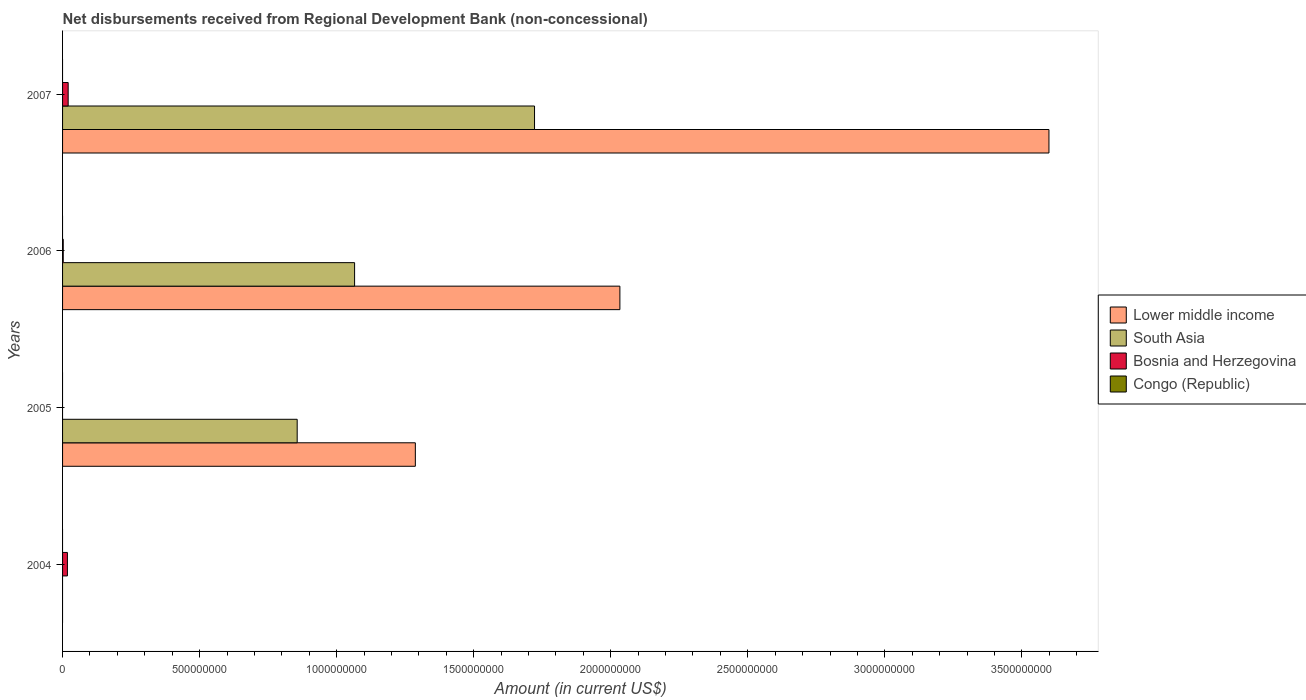Are the number of bars on each tick of the Y-axis equal?
Give a very brief answer. No. How many bars are there on the 2nd tick from the bottom?
Provide a short and direct response. 2. In how many cases, is the number of bars for a given year not equal to the number of legend labels?
Keep it short and to the point. 4. Across all years, what is the maximum amount of disbursements received from Regional Development Bank in Lower middle income?
Your answer should be compact. 3.60e+09. What is the total amount of disbursements received from Regional Development Bank in Congo (Republic) in the graph?
Give a very brief answer. 0. What is the difference between the amount of disbursements received from Regional Development Bank in South Asia in 2005 and that in 2007?
Provide a succinct answer. -8.66e+08. What is the difference between the amount of disbursements received from Regional Development Bank in South Asia in 2004 and the amount of disbursements received from Regional Development Bank in Bosnia and Herzegovina in 2007?
Ensure brevity in your answer.  -2.04e+07. What is the average amount of disbursements received from Regional Development Bank in Congo (Republic) per year?
Ensure brevity in your answer.  0. In the year 2007, what is the difference between the amount of disbursements received from Regional Development Bank in Lower middle income and amount of disbursements received from Regional Development Bank in South Asia?
Give a very brief answer. 1.88e+09. Is the difference between the amount of disbursements received from Regional Development Bank in Lower middle income in 2006 and 2007 greater than the difference between the amount of disbursements received from Regional Development Bank in South Asia in 2006 and 2007?
Give a very brief answer. No. What is the difference between the highest and the second highest amount of disbursements received from Regional Development Bank in South Asia?
Your answer should be very brief. 6.56e+08. What is the difference between the highest and the lowest amount of disbursements received from Regional Development Bank in Lower middle income?
Give a very brief answer. 3.60e+09. Is the sum of the amount of disbursements received from Regional Development Bank in South Asia in 2005 and 2007 greater than the maximum amount of disbursements received from Regional Development Bank in Lower middle income across all years?
Offer a terse response. No. Is it the case that in every year, the sum of the amount of disbursements received from Regional Development Bank in South Asia and amount of disbursements received from Regional Development Bank in Lower middle income is greater than the amount of disbursements received from Regional Development Bank in Congo (Republic)?
Offer a very short reply. No. How many bars are there?
Provide a short and direct response. 9. Are all the bars in the graph horizontal?
Your answer should be very brief. Yes. Does the graph contain grids?
Offer a very short reply. No. Where does the legend appear in the graph?
Keep it short and to the point. Center right. What is the title of the graph?
Make the answer very short. Net disbursements received from Regional Development Bank (non-concessional). What is the label or title of the Y-axis?
Offer a terse response. Years. What is the Amount (in current US$) of Bosnia and Herzegovina in 2004?
Your answer should be very brief. 1.77e+07. What is the Amount (in current US$) of Congo (Republic) in 2004?
Your response must be concise. 0. What is the Amount (in current US$) in Lower middle income in 2005?
Ensure brevity in your answer.  1.29e+09. What is the Amount (in current US$) in South Asia in 2005?
Your answer should be compact. 8.56e+08. What is the Amount (in current US$) in Bosnia and Herzegovina in 2005?
Offer a terse response. 0. What is the Amount (in current US$) in Lower middle income in 2006?
Offer a very short reply. 2.03e+09. What is the Amount (in current US$) of South Asia in 2006?
Keep it short and to the point. 1.07e+09. What is the Amount (in current US$) in Bosnia and Herzegovina in 2006?
Give a very brief answer. 2.46e+06. What is the Amount (in current US$) of Lower middle income in 2007?
Provide a short and direct response. 3.60e+09. What is the Amount (in current US$) in South Asia in 2007?
Your answer should be very brief. 1.72e+09. What is the Amount (in current US$) in Bosnia and Herzegovina in 2007?
Keep it short and to the point. 2.04e+07. Across all years, what is the maximum Amount (in current US$) of Lower middle income?
Your answer should be compact. 3.60e+09. Across all years, what is the maximum Amount (in current US$) in South Asia?
Your response must be concise. 1.72e+09. Across all years, what is the maximum Amount (in current US$) of Bosnia and Herzegovina?
Your answer should be very brief. 2.04e+07. Across all years, what is the minimum Amount (in current US$) of Lower middle income?
Make the answer very short. 0. What is the total Amount (in current US$) of Lower middle income in the graph?
Provide a succinct answer. 6.92e+09. What is the total Amount (in current US$) of South Asia in the graph?
Provide a short and direct response. 3.64e+09. What is the total Amount (in current US$) of Bosnia and Herzegovina in the graph?
Offer a terse response. 4.06e+07. What is the difference between the Amount (in current US$) in Bosnia and Herzegovina in 2004 and that in 2006?
Your response must be concise. 1.53e+07. What is the difference between the Amount (in current US$) in Bosnia and Herzegovina in 2004 and that in 2007?
Make the answer very short. -2.73e+06. What is the difference between the Amount (in current US$) in Lower middle income in 2005 and that in 2006?
Your answer should be compact. -7.46e+08. What is the difference between the Amount (in current US$) in South Asia in 2005 and that in 2006?
Keep it short and to the point. -2.09e+08. What is the difference between the Amount (in current US$) of Lower middle income in 2005 and that in 2007?
Keep it short and to the point. -2.31e+09. What is the difference between the Amount (in current US$) in South Asia in 2005 and that in 2007?
Offer a terse response. -8.66e+08. What is the difference between the Amount (in current US$) of Lower middle income in 2006 and that in 2007?
Provide a short and direct response. -1.57e+09. What is the difference between the Amount (in current US$) of South Asia in 2006 and that in 2007?
Your response must be concise. -6.56e+08. What is the difference between the Amount (in current US$) of Bosnia and Herzegovina in 2006 and that in 2007?
Keep it short and to the point. -1.80e+07. What is the difference between the Amount (in current US$) of Lower middle income in 2005 and the Amount (in current US$) of South Asia in 2006?
Offer a terse response. 2.22e+08. What is the difference between the Amount (in current US$) of Lower middle income in 2005 and the Amount (in current US$) of Bosnia and Herzegovina in 2006?
Provide a short and direct response. 1.28e+09. What is the difference between the Amount (in current US$) in South Asia in 2005 and the Amount (in current US$) in Bosnia and Herzegovina in 2006?
Ensure brevity in your answer.  8.54e+08. What is the difference between the Amount (in current US$) in Lower middle income in 2005 and the Amount (in current US$) in South Asia in 2007?
Keep it short and to the point. -4.35e+08. What is the difference between the Amount (in current US$) of Lower middle income in 2005 and the Amount (in current US$) of Bosnia and Herzegovina in 2007?
Provide a succinct answer. 1.27e+09. What is the difference between the Amount (in current US$) in South Asia in 2005 and the Amount (in current US$) in Bosnia and Herzegovina in 2007?
Your response must be concise. 8.36e+08. What is the difference between the Amount (in current US$) of Lower middle income in 2006 and the Amount (in current US$) of South Asia in 2007?
Give a very brief answer. 3.11e+08. What is the difference between the Amount (in current US$) of Lower middle income in 2006 and the Amount (in current US$) of Bosnia and Herzegovina in 2007?
Your answer should be very brief. 2.01e+09. What is the difference between the Amount (in current US$) of South Asia in 2006 and the Amount (in current US$) of Bosnia and Herzegovina in 2007?
Ensure brevity in your answer.  1.04e+09. What is the average Amount (in current US$) in Lower middle income per year?
Make the answer very short. 1.73e+09. What is the average Amount (in current US$) in South Asia per year?
Provide a short and direct response. 9.11e+08. What is the average Amount (in current US$) of Bosnia and Herzegovina per year?
Provide a succinct answer. 1.02e+07. What is the average Amount (in current US$) in Congo (Republic) per year?
Provide a short and direct response. 0. In the year 2005, what is the difference between the Amount (in current US$) of Lower middle income and Amount (in current US$) of South Asia?
Offer a very short reply. 4.31e+08. In the year 2006, what is the difference between the Amount (in current US$) of Lower middle income and Amount (in current US$) of South Asia?
Provide a succinct answer. 9.68e+08. In the year 2006, what is the difference between the Amount (in current US$) of Lower middle income and Amount (in current US$) of Bosnia and Herzegovina?
Provide a succinct answer. 2.03e+09. In the year 2006, what is the difference between the Amount (in current US$) of South Asia and Amount (in current US$) of Bosnia and Herzegovina?
Offer a very short reply. 1.06e+09. In the year 2007, what is the difference between the Amount (in current US$) of Lower middle income and Amount (in current US$) of South Asia?
Keep it short and to the point. 1.88e+09. In the year 2007, what is the difference between the Amount (in current US$) of Lower middle income and Amount (in current US$) of Bosnia and Herzegovina?
Your answer should be very brief. 3.58e+09. In the year 2007, what is the difference between the Amount (in current US$) in South Asia and Amount (in current US$) in Bosnia and Herzegovina?
Ensure brevity in your answer.  1.70e+09. What is the ratio of the Amount (in current US$) in Bosnia and Herzegovina in 2004 to that in 2006?
Offer a terse response. 7.21. What is the ratio of the Amount (in current US$) in Bosnia and Herzegovina in 2004 to that in 2007?
Keep it short and to the point. 0.87. What is the ratio of the Amount (in current US$) in Lower middle income in 2005 to that in 2006?
Provide a succinct answer. 0.63. What is the ratio of the Amount (in current US$) in South Asia in 2005 to that in 2006?
Provide a succinct answer. 0.8. What is the ratio of the Amount (in current US$) of Lower middle income in 2005 to that in 2007?
Your response must be concise. 0.36. What is the ratio of the Amount (in current US$) in South Asia in 2005 to that in 2007?
Keep it short and to the point. 0.5. What is the ratio of the Amount (in current US$) in Lower middle income in 2006 to that in 2007?
Ensure brevity in your answer.  0.56. What is the ratio of the Amount (in current US$) in South Asia in 2006 to that in 2007?
Ensure brevity in your answer.  0.62. What is the ratio of the Amount (in current US$) in Bosnia and Herzegovina in 2006 to that in 2007?
Provide a short and direct response. 0.12. What is the difference between the highest and the second highest Amount (in current US$) of Lower middle income?
Give a very brief answer. 1.57e+09. What is the difference between the highest and the second highest Amount (in current US$) in South Asia?
Your answer should be compact. 6.56e+08. What is the difference between the highest and the second highest Amount (in current US$) in Bosnia and Herzegovina?
Your response must be concise. 2.73e+06. What is the difference between the highest and the lowest Amount (in current US$) in Lower middle income?
Provide a succinct answer. 3.60e+09. What is the difference between the highest and the lowest Amount (in current US$) of South Asia?
Offer a terse response. 1.72e+09. What is the difference between the highest and the lowest Amount (in current US$) of Bosnia and Herzegovina?
Provide a succinct answer. 2.04e+07. 